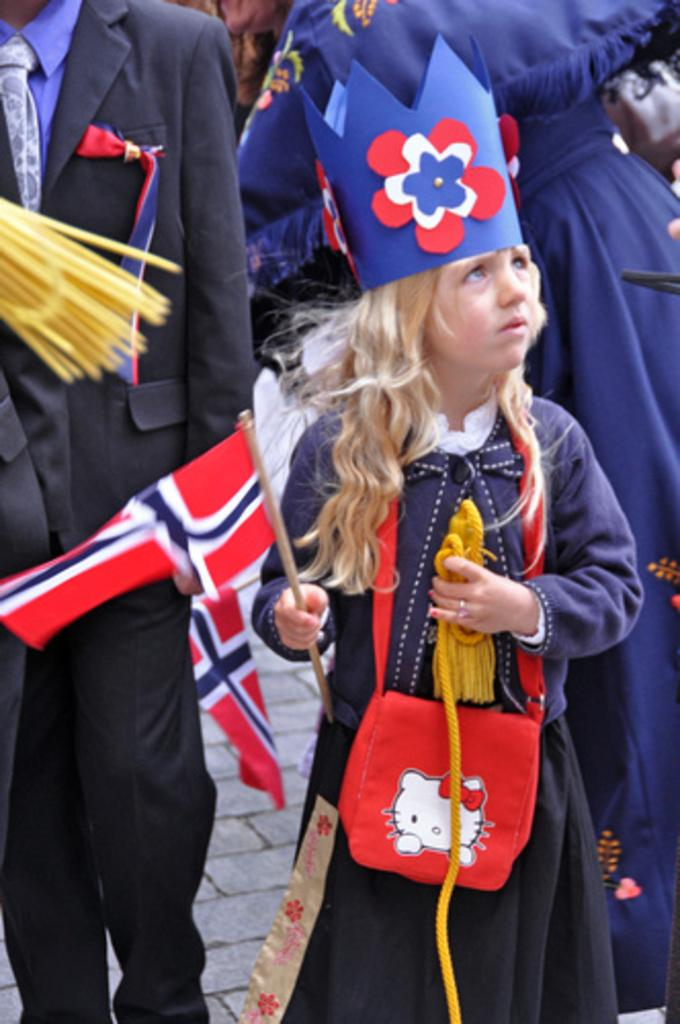Who are the subjects in the image? There are people in the image. Can you describe the position of the girl in the group? A girl is in the front of the group. What is the girl holding in her hands? The girl is holding objects in her hands. What distinguishes the girl from the others in the image? The girl is wearing a crown. What type of waste can be seen in the image? There is no waste present in the image. What drug is the girl taking in the image? There is no drug present in the image. 